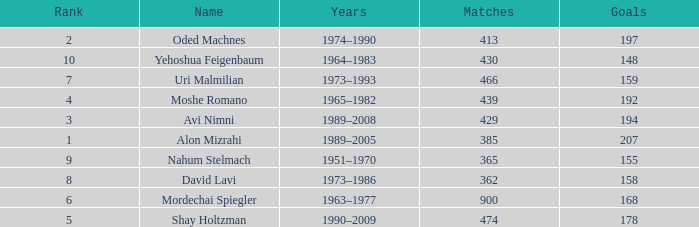What is the Rank of the player with 362 Matches? 8.0. 